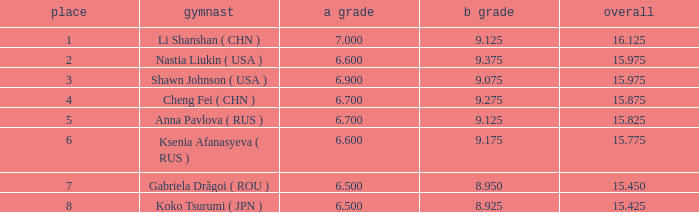What's the total that the position is less than 1? None. 